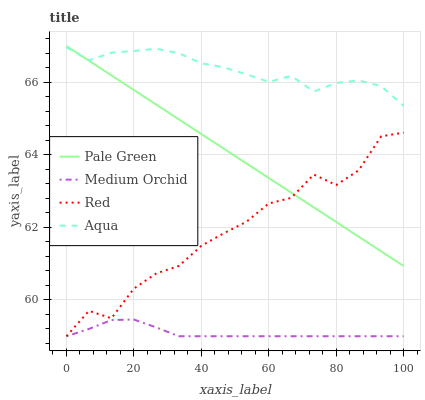Does Medium Orchid have the minimum area under the curve?
Answer yes or no. Yes. Does Aqua have the maximum area under the curve?
Answer yes or no. Yes. Does Pale Green have the minimum area under the curve?
Answer yes or no. No. Does Pale Green have the maximum area under the curve?
Answer yes or no. No. Is Pale Green the smoothest?
Answer yes or no. Yes. Is Red the roughest?
Answer yes or no. Yes. Is Aqua the smoothest?
Answer yes or no. No. Is Aqua the roughest?
Answer yes or no. No. Does Medium Orchid have the lowest value?
Answer yes or no. Yes. Does Pale Green have the lowest value?
Answer yes or no. No. Does Pale Green have the highest value?
Answer yes or no. Yes. Does Aqua have the highest value?
Answer yes or no. No. Is Red less than Aqua?
Answer yes or no. Yes. Is Aqua greater than Medium Orchid?
Answer yes or no. Yes. Does Red intersect Pale Green?
Answer yes or no. Yes. Is Red less than Pale Green?
Answer yes or no. No. Is Red greater than Pale Green?
Answer yes or no. No. Does Red intersect Aqua?
Answer yes or no. No. 